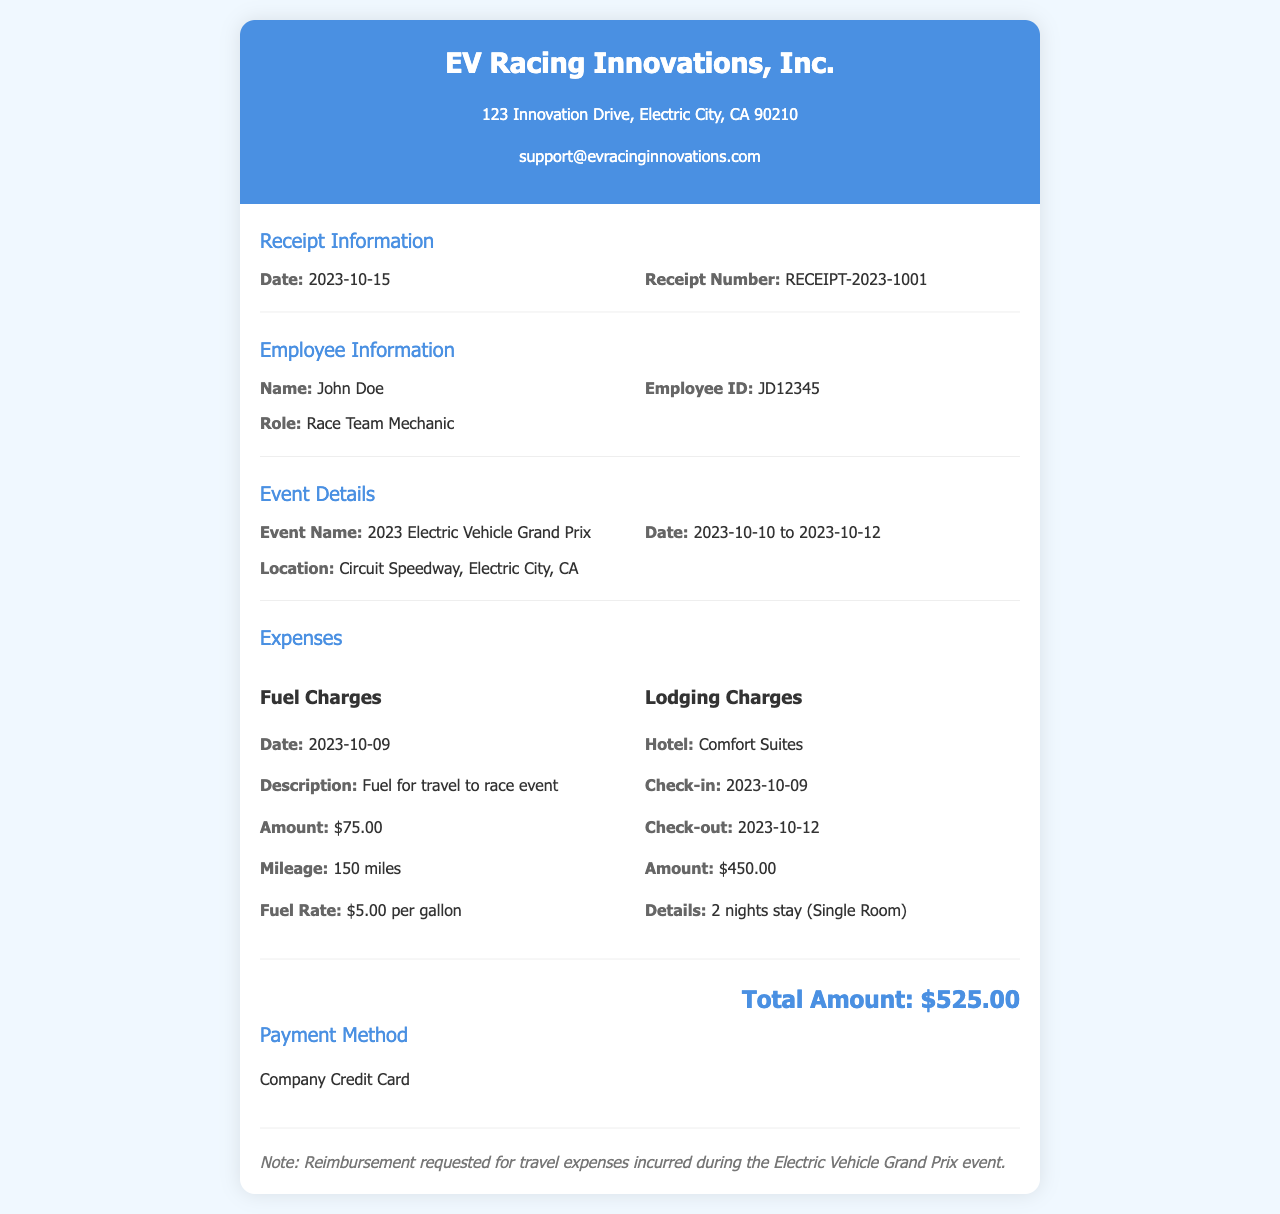what is the employee name? The employee's name is found in the Employee Information section of the document.
Answer: John Doe what is the total amount of expenses? The total amount is mentioned at the end of the Expenses section, summing up all individual expenses.
Answer: $525.00 what event did the employee attend? The event attended is specified in the Event Details section, detailing the purpose of the travel.
Answer: 2023 Electric Vehicle Grand Prix when was the lodging check-out date? The check-out date can be found in the Lodging Charges section under Hotel details.
Answer: 2023-10-12 how much was charged for fuel? The fuel charge amount is clearly listed in the Fuel Charges section of the receipt.
Answer: $75.00 what is the employee's role? The employee's role is specified in the Employee Information section of the document.
Answer: Race Team Mechanic what hotel did the employee stay at? The hotel name is provided in the Lodging Charges section of the document.
Answer: Comfort Suites how many nights did the employee stay? The duration of the stay is detailed in the Lodging Charges section regarding the hotel booking.
Answer: 2 nights what method was used for payment? The method of payment is mentioned in the Payment Method section of the receipt.
Answer: Company Credit Card 